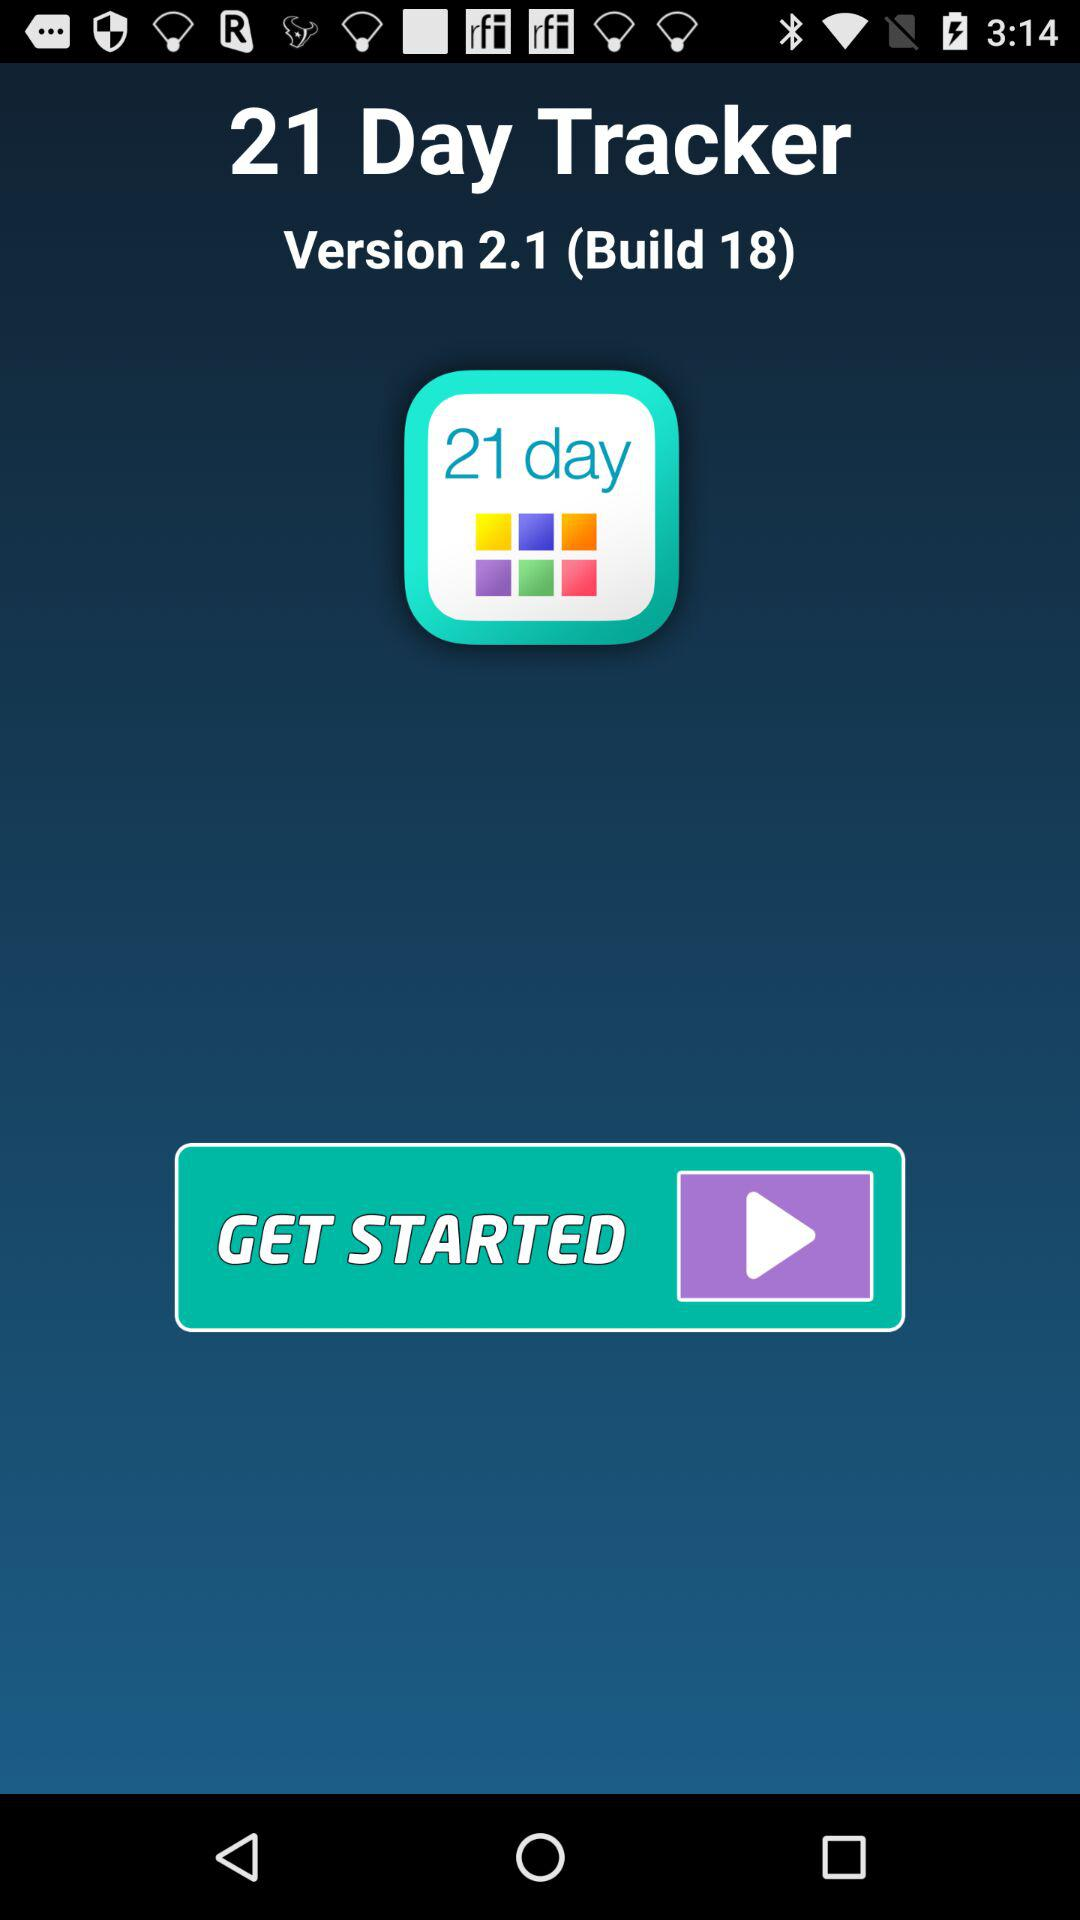What is the build version given? The build version is 2.1. 